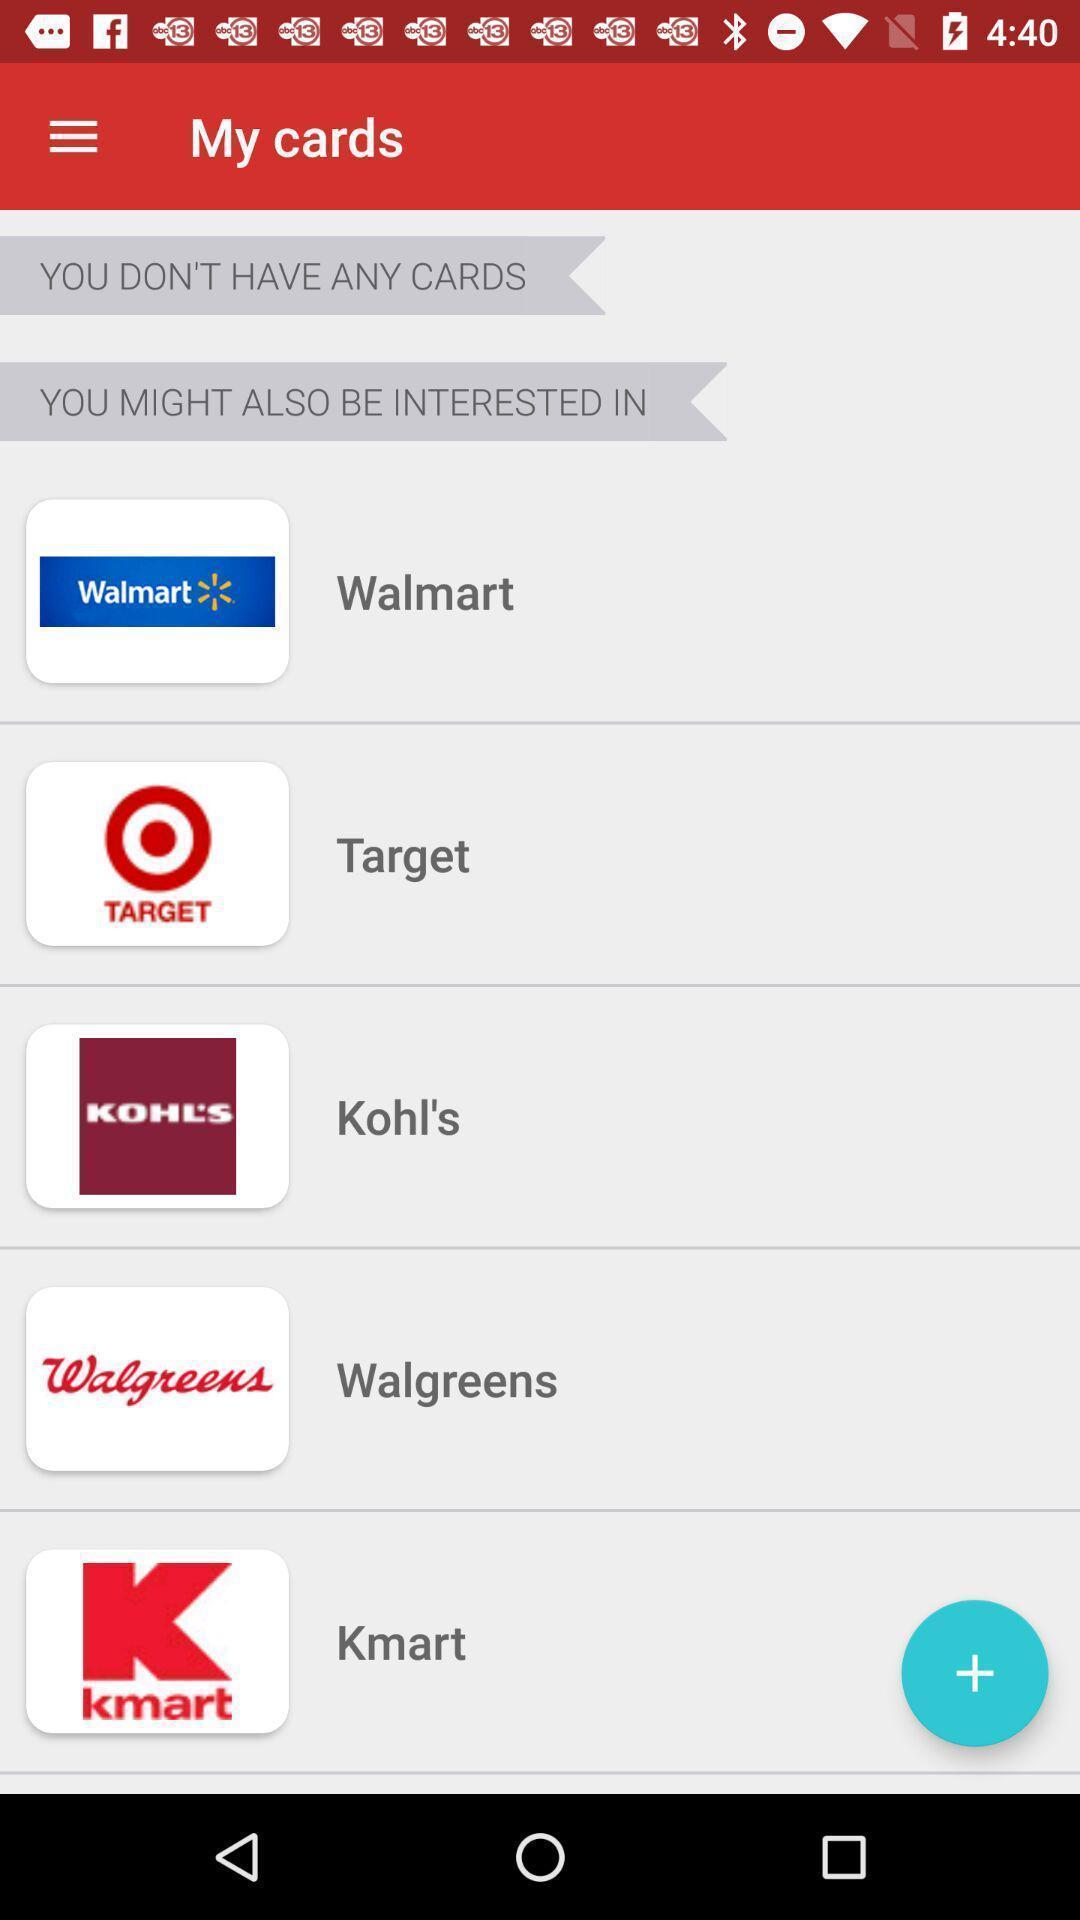Provide a detailed account of this screenshot. Various grocery stores displayed. 